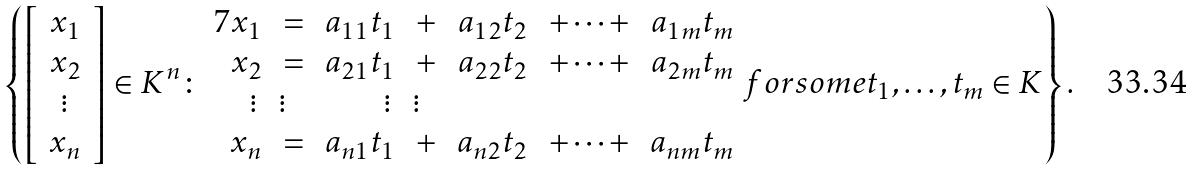<formula> <loc_0><loc_0><loc_500><loc_500>\left \{ \left [ \, { \begin{array} { c } { x _ { 1 } } \\ { x _ { 2 } } \\ { \vdots } \\ { x _ { n } } \end{array} } \, \right ] \in K ^ { n } \colon { \begin{array} { r l r l r l r l r l r l r l } { { 7 } x _ { 1 } } & { \, = \, } & { a _ { 1 1 } t _ { 1 } } & { \, + \, } & { a _ { 1 2 } t _ { 2 } } & { \, + \cdots + \, } & { a _ { 1 m } t _ { m } } \\ { x _ { 2 } } & { \, = \, } & { a _ { 2 1 } t _ { 1 } } & { \, + \, } & { a _ { 2 2 } t _ { 2 } } & { \, + \cdots + \, } & { a _ { 2 m } t _ { m } } \\ { \vdots \, } & { \vdots \, } & { \vdots \, } & { \vdots \, } \\ { x _ { n } } & { \, = \, } & { a _ { n 1 } t _ { 1 } } & { \, + \, } & { a _ { n 2 } t _ { 2 } } & { \, + \cdots + \, } & { a _ { n m } t _ { m } } \end{array} } { f o r s o m e } t _ { 1 } , \dots , t _ { m } \in K \right \} .</formula> 